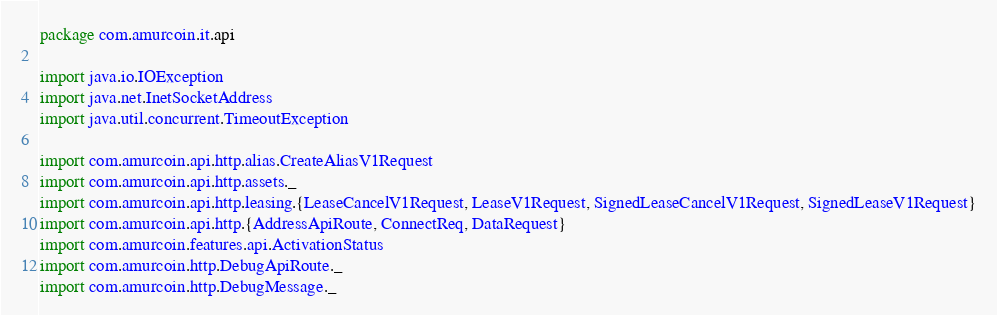Convert code to text. <code><loc_0><loc_0><loc_500><loc_500><_Scala_>package com.amurcoin.it.api

import java.io.IOException
import java.net.InetSocketAddress
import java.util.concurrent.TimeoutException

import com.amurcoin.api.http.alias.CreateAliasV1Request
import com.amurcoin.api.http.assets._
import com.amurcoin.api.http.leasing.{LeaseCancelV1Request, LeaseV1Request, SignedLeaseCancelV1Request, SignedLeaseV1Request}
import com.amurcoin.api.http.{AddressApiRoute, ConnectReq, DataRequest}
import com.amurcoin.features.api.ActivationStatus
import com.amurcoin.http.DebugApiRoute._
import com.amurcoin.http.DebugMessage._</code> 